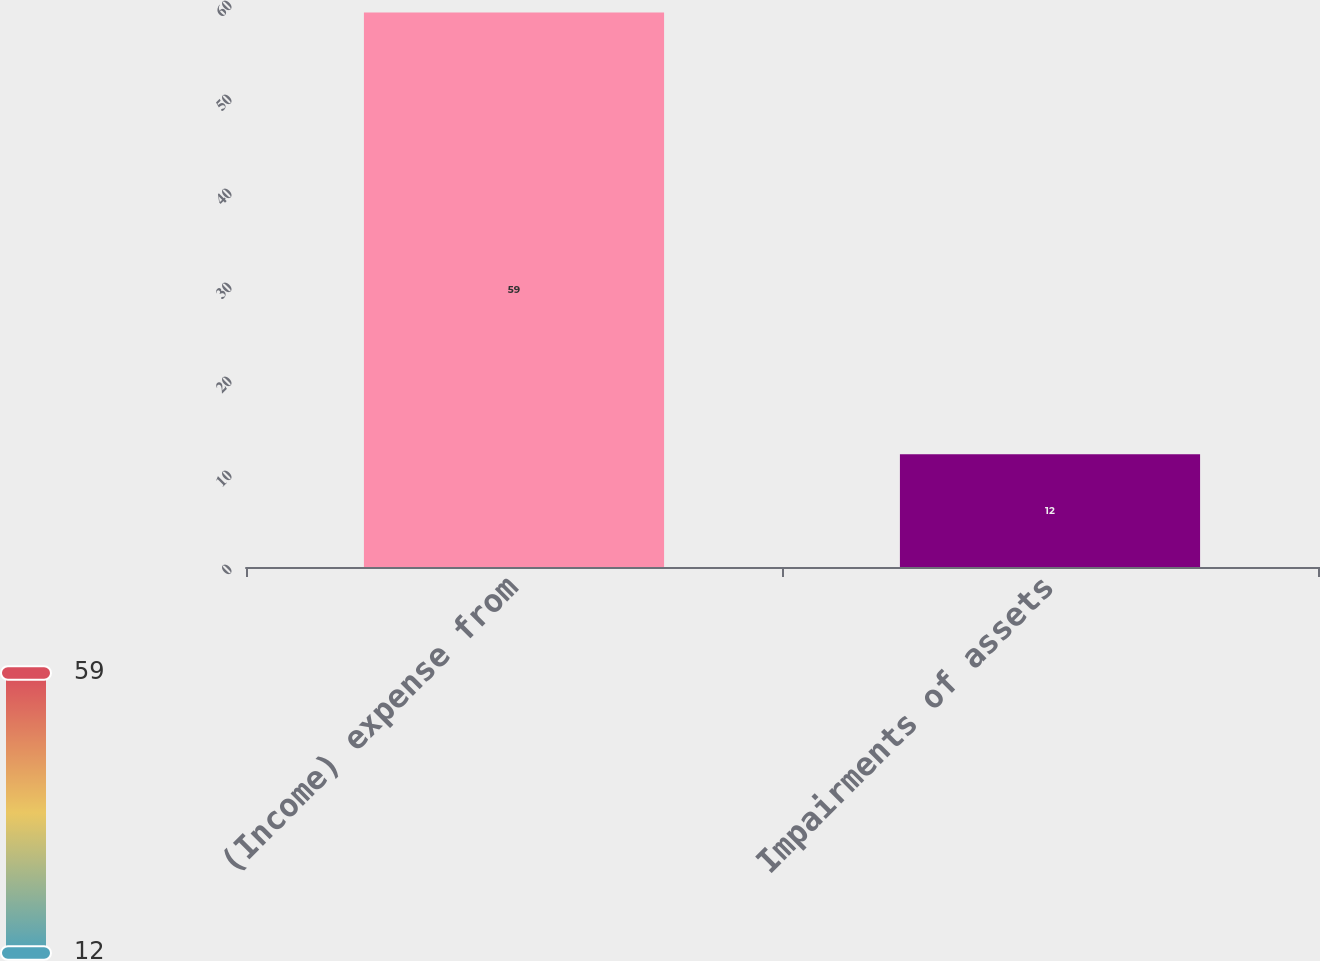Convert chart to OTSL. <chart><loc_0><loc_0><loc_500><loc_500><bar_chart><fcel>(Income) expense from<fcel>Impairments of assets<nl><fcel>59<fcel>12<nl></chart> 